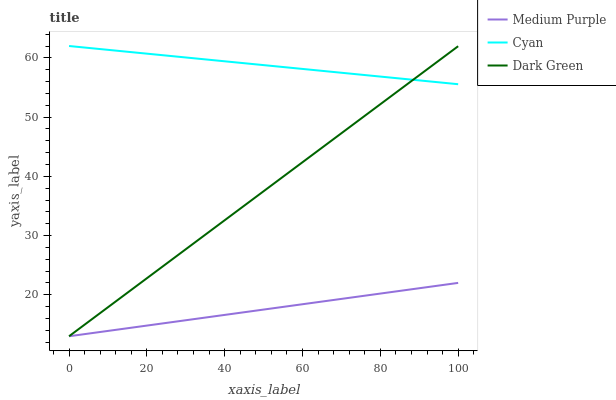Does Medium Purple have the minimum area under the curve?
Answer yes or no. Yes. Does Cyan have the maximum area under the curve?
Answer yes or no. Yes. Does Dark Green have the minimum area under the curve?
Answer yes or no. No. Does Dark Green have the maximum area under the curve?
Answer yes or no. No. Is Dark Green the smoothest?
Answer yes or no. Yes. Is Cyan the roughest?
Answer yes or no. Yes. Is Cyan the smoothest?
Answer yes or no. No. Is Dark Green the roughest?
Answer yes or no. No. Does Cyan have the lowest value?
Answer yes or no. No. Does Cyan have the highest value?
Answer yes or no. Yes. Does Dark Green have the highest value?
Answer yes or no. No. Is Medium Purple less than Cyan?
Answer yes or no. Yes. Is Cyan greater than Medium Purple?
Answer yes or no. Yes. Does Medium Purple intersect Cyan?
Answer yes or no. No. 